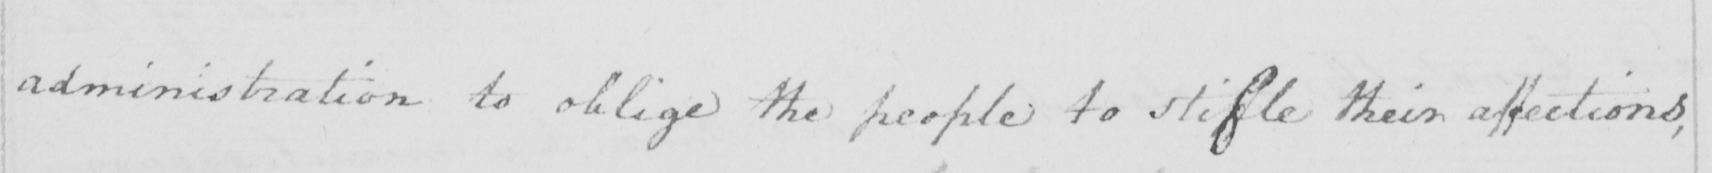Can you read and transcribe this handwriting? administration to oblige the people to stifle their affections , 